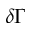Convert formula to latex. <formula><loc_0><loc_0><loc_500><loc_500>\delta \Gamma</formula> 